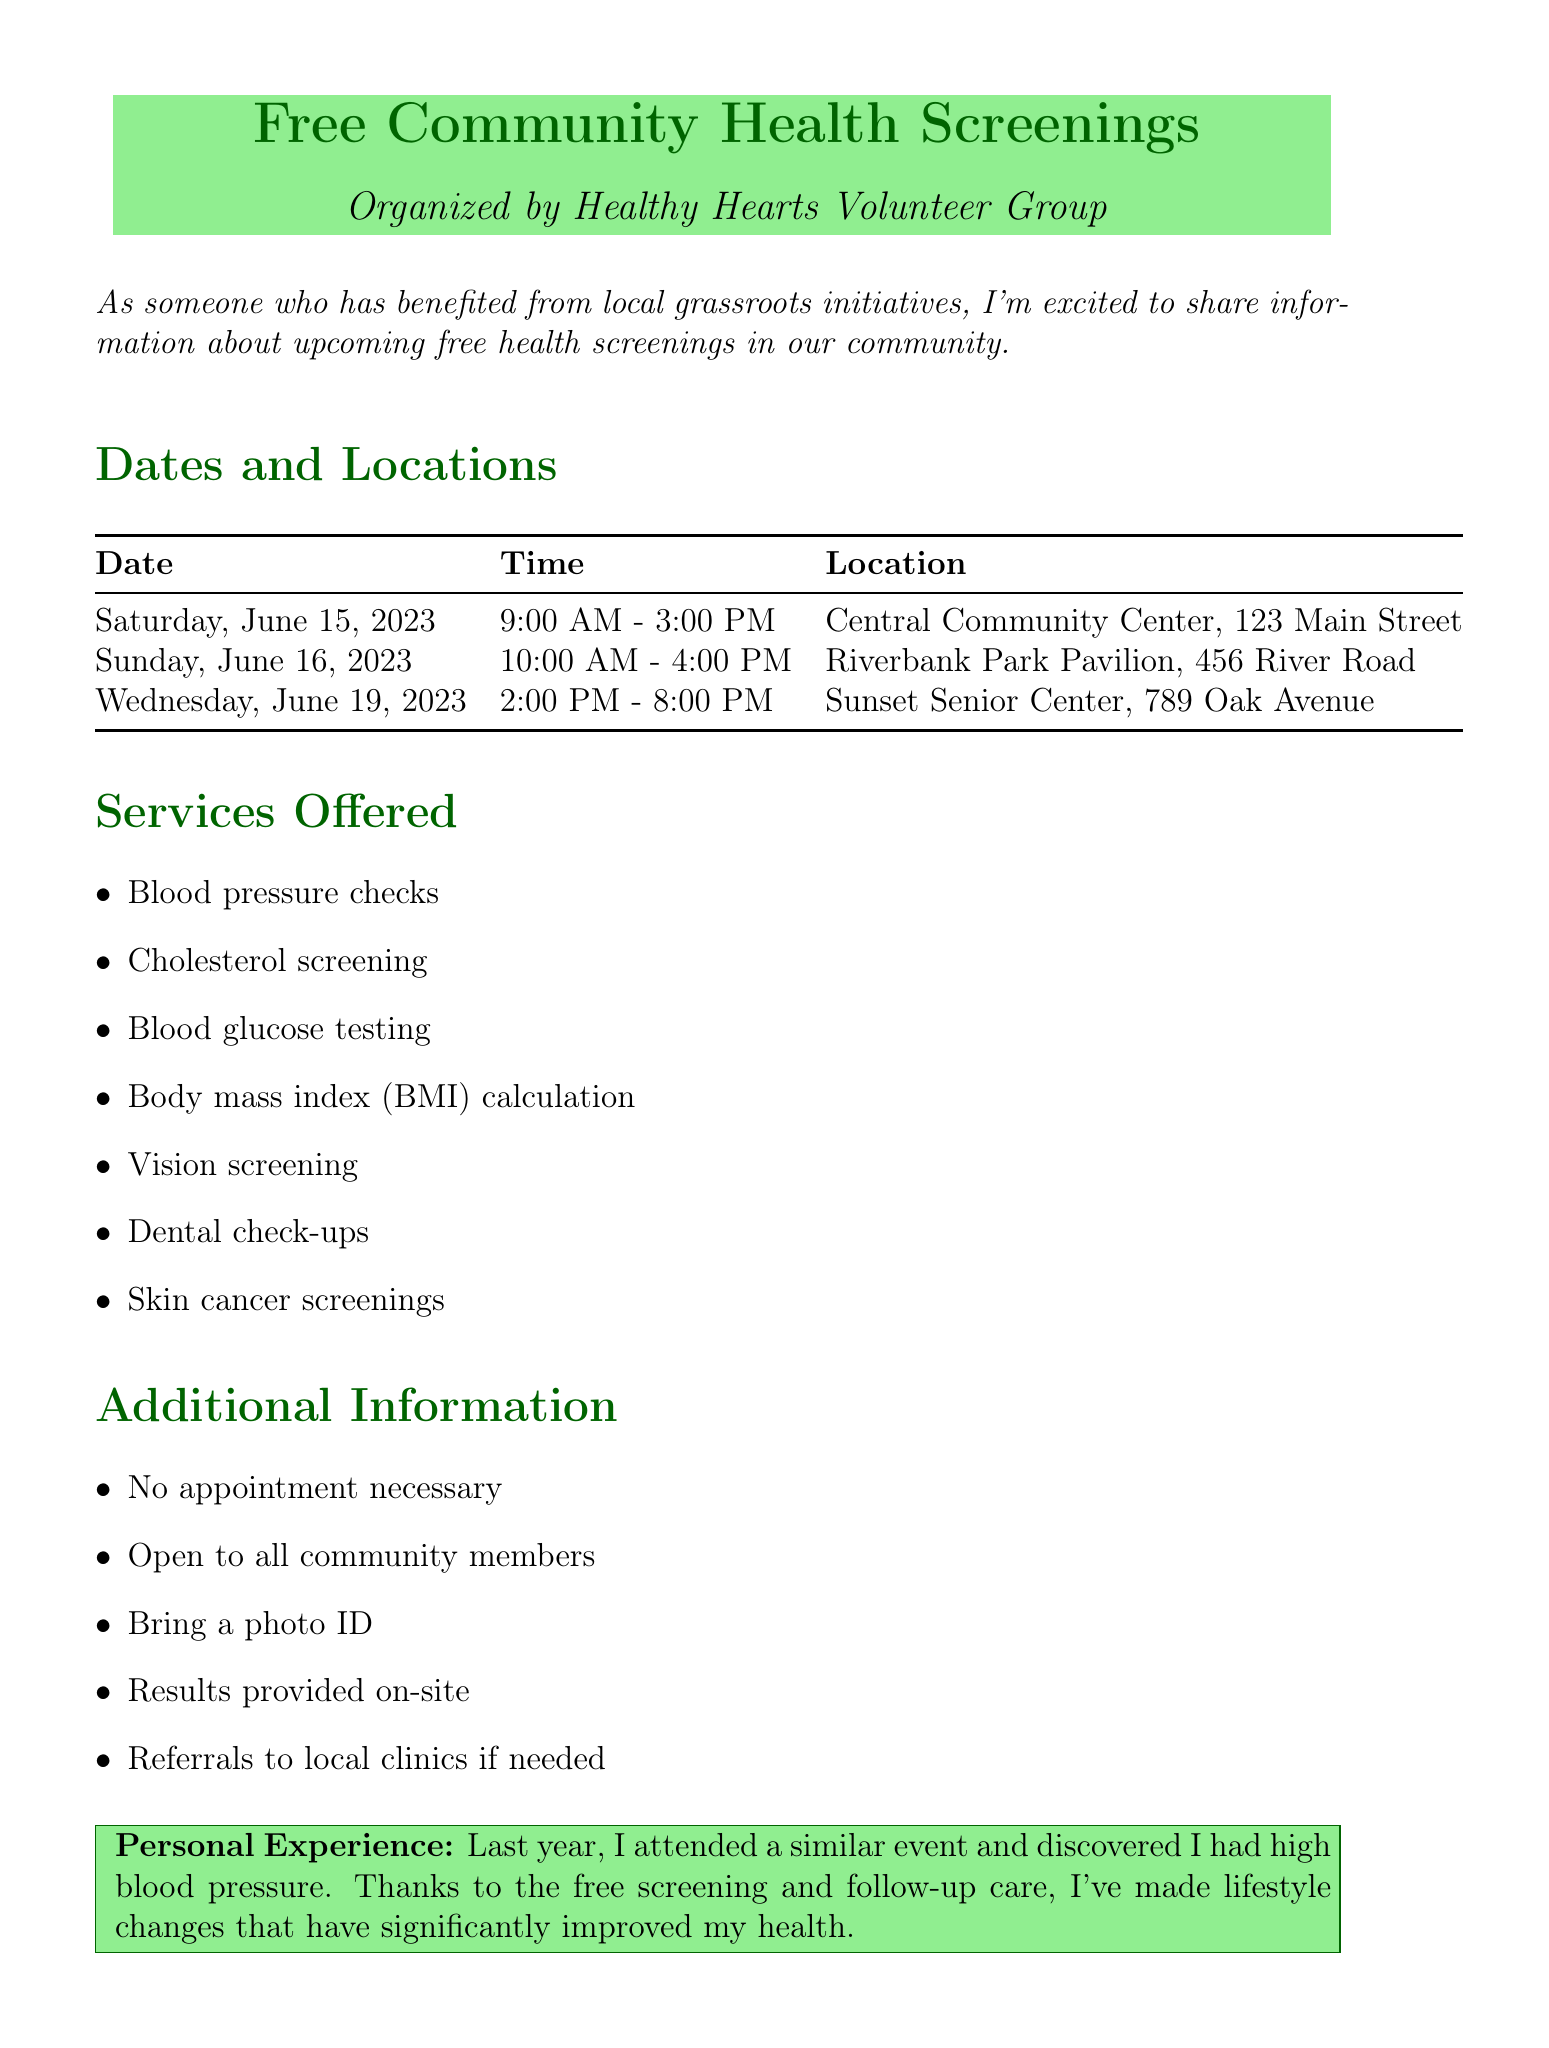What is the name of the organizing group? The organizing group is identified in the document as the Healthy Hearts Volunteer Group.
Answer: Healthy Hearts Volunteer Group How many screening dates are mentioned? The document lists three different screening dates, detailing services and locations for each.
Answer: 3 What service is offered for measuring body fat? The document explicitly mentions the calculation of body mass index (BMI) as one of the services offered.
Answer: Body mass index (BMI) calculation What is the time for the screening on June 16, 2023? The document specifies the time for the screening on June 16, 2023, providing exact hours for that date.
Answer: 10:00 AM - 4:00 PM Is there a requirement for appointments? The document states that no appointment is necessary for the screenings, which is crucial for participation.
Answer: No Who should attendees contact for volunteer opportunities? The document provides contact information for volunteer opportunities, specifying a person responsible for those inquiries.
Answer: Jane Smith What experience did the author share? The author recounts a personal experience related to a previous screening, highlighting the positive impact on their health.
Answer: Discovered I had high blood pressure What is required to participate in the screenings? The document notes that attendees should bring a photo ID when participating in the screenings, which is an important requirement.
Answer: Photo ID What is the contact number for questions about the event? The document provides a specific phone number to contact for any questions regarding the health screenings.
Answer: (555) 987-6543 